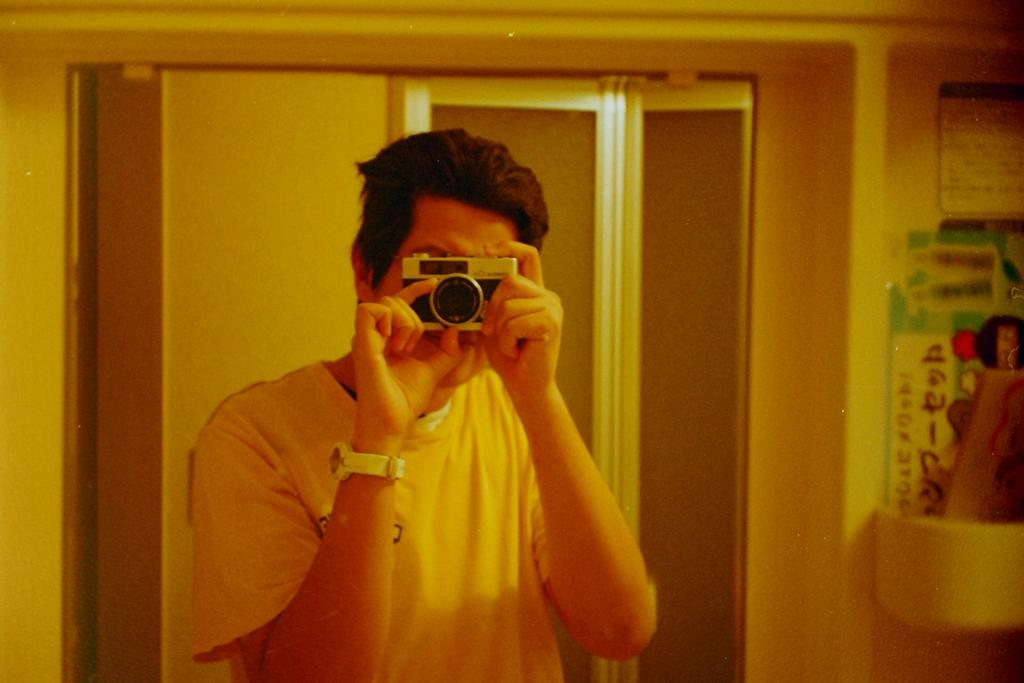What is the person in the image holding? The person in the image is holding a camera. What can be seen in the background of the image? There are boards attached to a wall in the background of the image. What type of request is the person making to the nation in the image? There is no indication in the image that the person is making a request to a nation, as the image only shows a person holding a camera and boards attached to a wall in the background. 